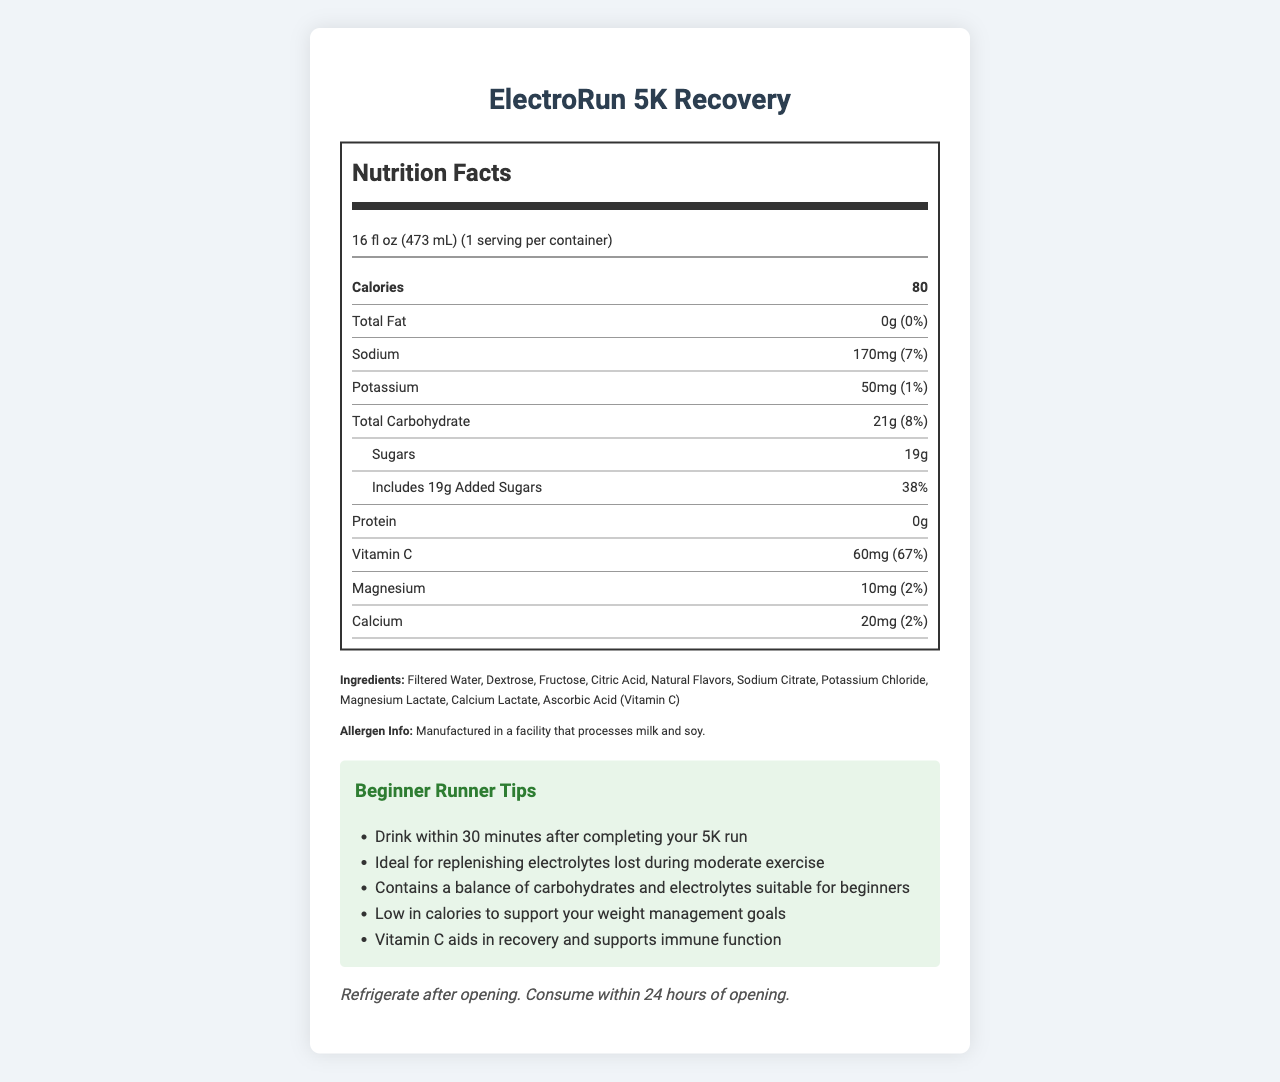what is the serving size of ElectroRun 5K Recovery? The serving size is clearly stated at the top of the Nutrition Facts section: "Serving size: 16 fl oz (473 mL)".
Answer: 16 fl oz (473 mL) how many calories are in one serving of the sports drink? The document mentions it under the Calories section: "Calories - 80".
Answer: 80 how much protein does this drink provide per serving? The amount of protein is listed in the Nutrition Facts section: "Protein - 0g".
Answer: 0g what is the percentage of the daily value for sodium in this drink? The document specifies the daily value for sodium as: "Sodium - 170mg (7%)".
Answer: 7% how much total carbohydrate is in this drink, and what percentage of the daily value does it represent? The document notes: "Total Carbohydrate - 21g (8%)".
Answer: 21g, 8% which vitamin in this drink has the highest percentage of the daily value? The document states the daily value percentage: "Vitamin C - 60mg (67%)".
Answer: Vitamin C how much added sugar is in the drink? The document includes detailed sugar information: "Includes 19g Added Sugars".
Answer: 19g what allergens might be present in this drink? The allergen information is mentioned: "Manufactured in a facility that processes milk and soy."
Answer: Milk and soy what is the main purpose of this product? A. Weight loss B. Muscle gain C. Replenishing electrolytes D. Improving stamina Based on the Beginner Runner Tips and the product summary, the main purpose is: "Ideal for replenishing electrolytes lost during moderate exercise".
Answer: C which of these ingredients is not in ElectroRun 5K Recovery? A. Dextrose B. Fructose C. Aspartame D. Calcium Lactate Aspartame is not listed in the ingredients: "Filtered Water, Dextrose, Fructose, Citric Acid, Natural Flavors, Sodium Citrate, Potassium Chloride, Magnesium Lactate, Calcium Lactate, Ascorbic Acid (Vitamin C)".
Answer: C is this drink low in calories? The document states it is low in calories: "80 calories per serving," and listed as a beginner runner tip.
Answer: Yes can you determine how much Vitamin D is in this drink? The document does not provide any information on Vitamin D content.
Answer: Cannot be determined summarize the main purpose and features of this sports drink. The product features highlight its main purpose of electrolyte replenishment after exercise, suitable for beginners. The document mentions ingredients, serving size, allergen information, and beginner runner tips emphasizing weight management and recovery support.
Answer: ElectroRun 5K Recovery is designed to replenish electrolytes lost during a 5K run. It contains 80 calories per serving with 21g of carbohydrates, 19g of sugars, and is enriched with Vitamin C, magnesium, and calcium. 